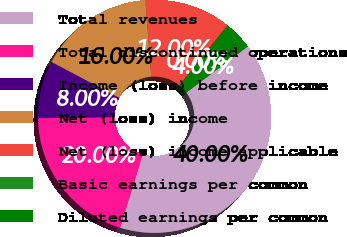Convert chart to OTSL. <chart><loc_0><loc_0><loc_500><loc_500><pie_chart><fcel>Total revenues<fcel>Total discontinued operations<fcel>Income (loss) before income<fcel>Net (loss) income<fcel>Net (loss) income applicable<fcel>Basic earnings per common<fcel>Diluted earnings per common<nl><fcel>40.0%<fcel>20.0%<fcel>8.0%<fcel>16.0%<fcel>12.0%<fcel>0.0%<fcel>4.0%<nl></chart> 